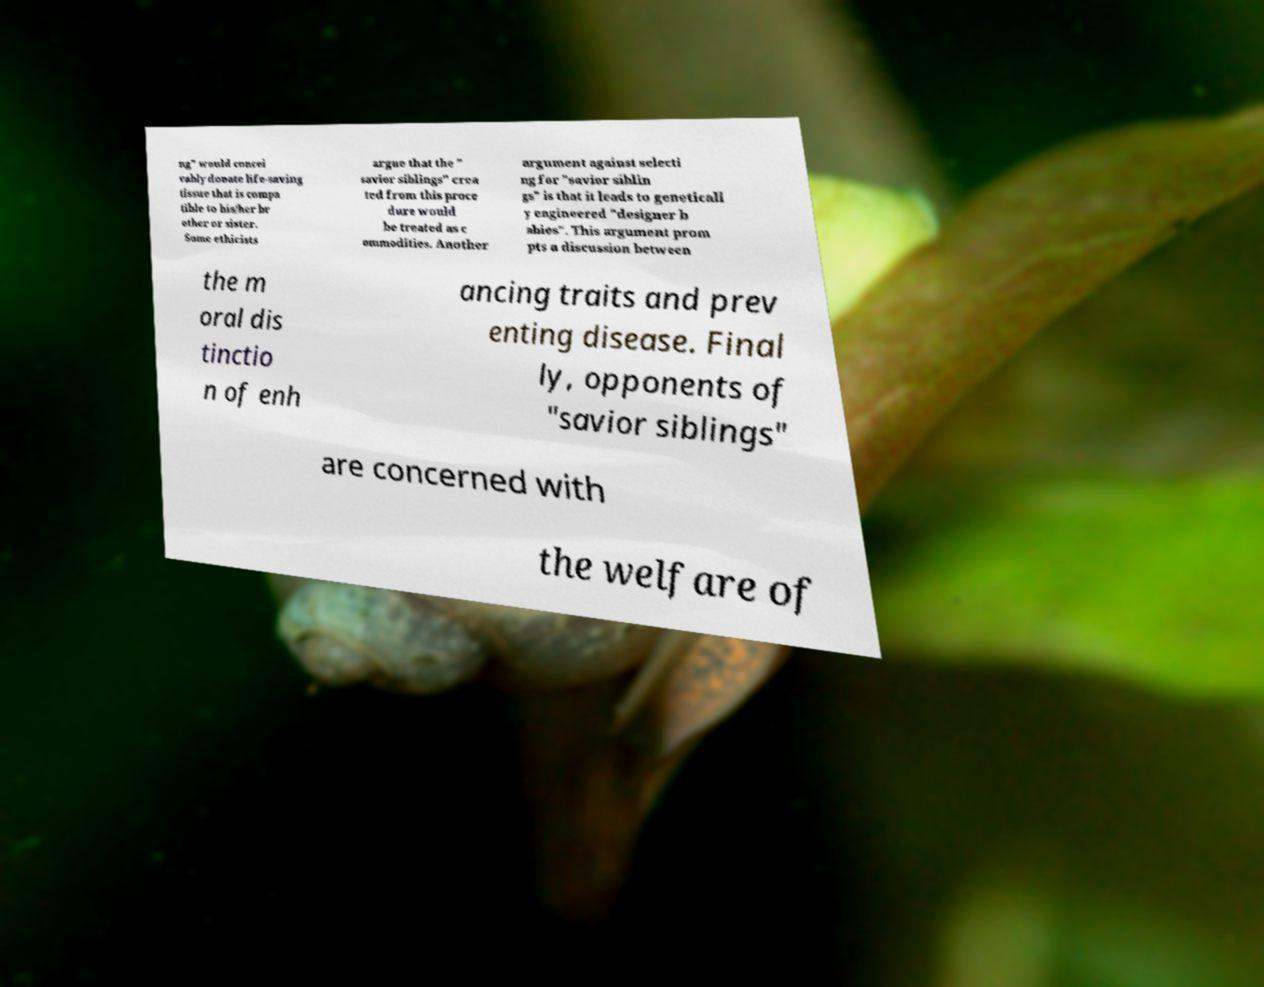Can you accurately transcribe the text from the provided image for me? ng" would concei vably donate life-saving tissue that is compa tible to his/her br other or sister. Some ethicists argue that the " savior siblings" crea ted from this proce dure would be treated as c ommodities. Another argument against selecti ng for "savior siblin gs" is that it leads to geneticall y engineered "designer b abies". This argument prom pts a discussion between the m oral dis tinctio n of enh ancing traits and prev enting disease. Final ly, opponents of "savior siblings" are concerned with the welfare of 